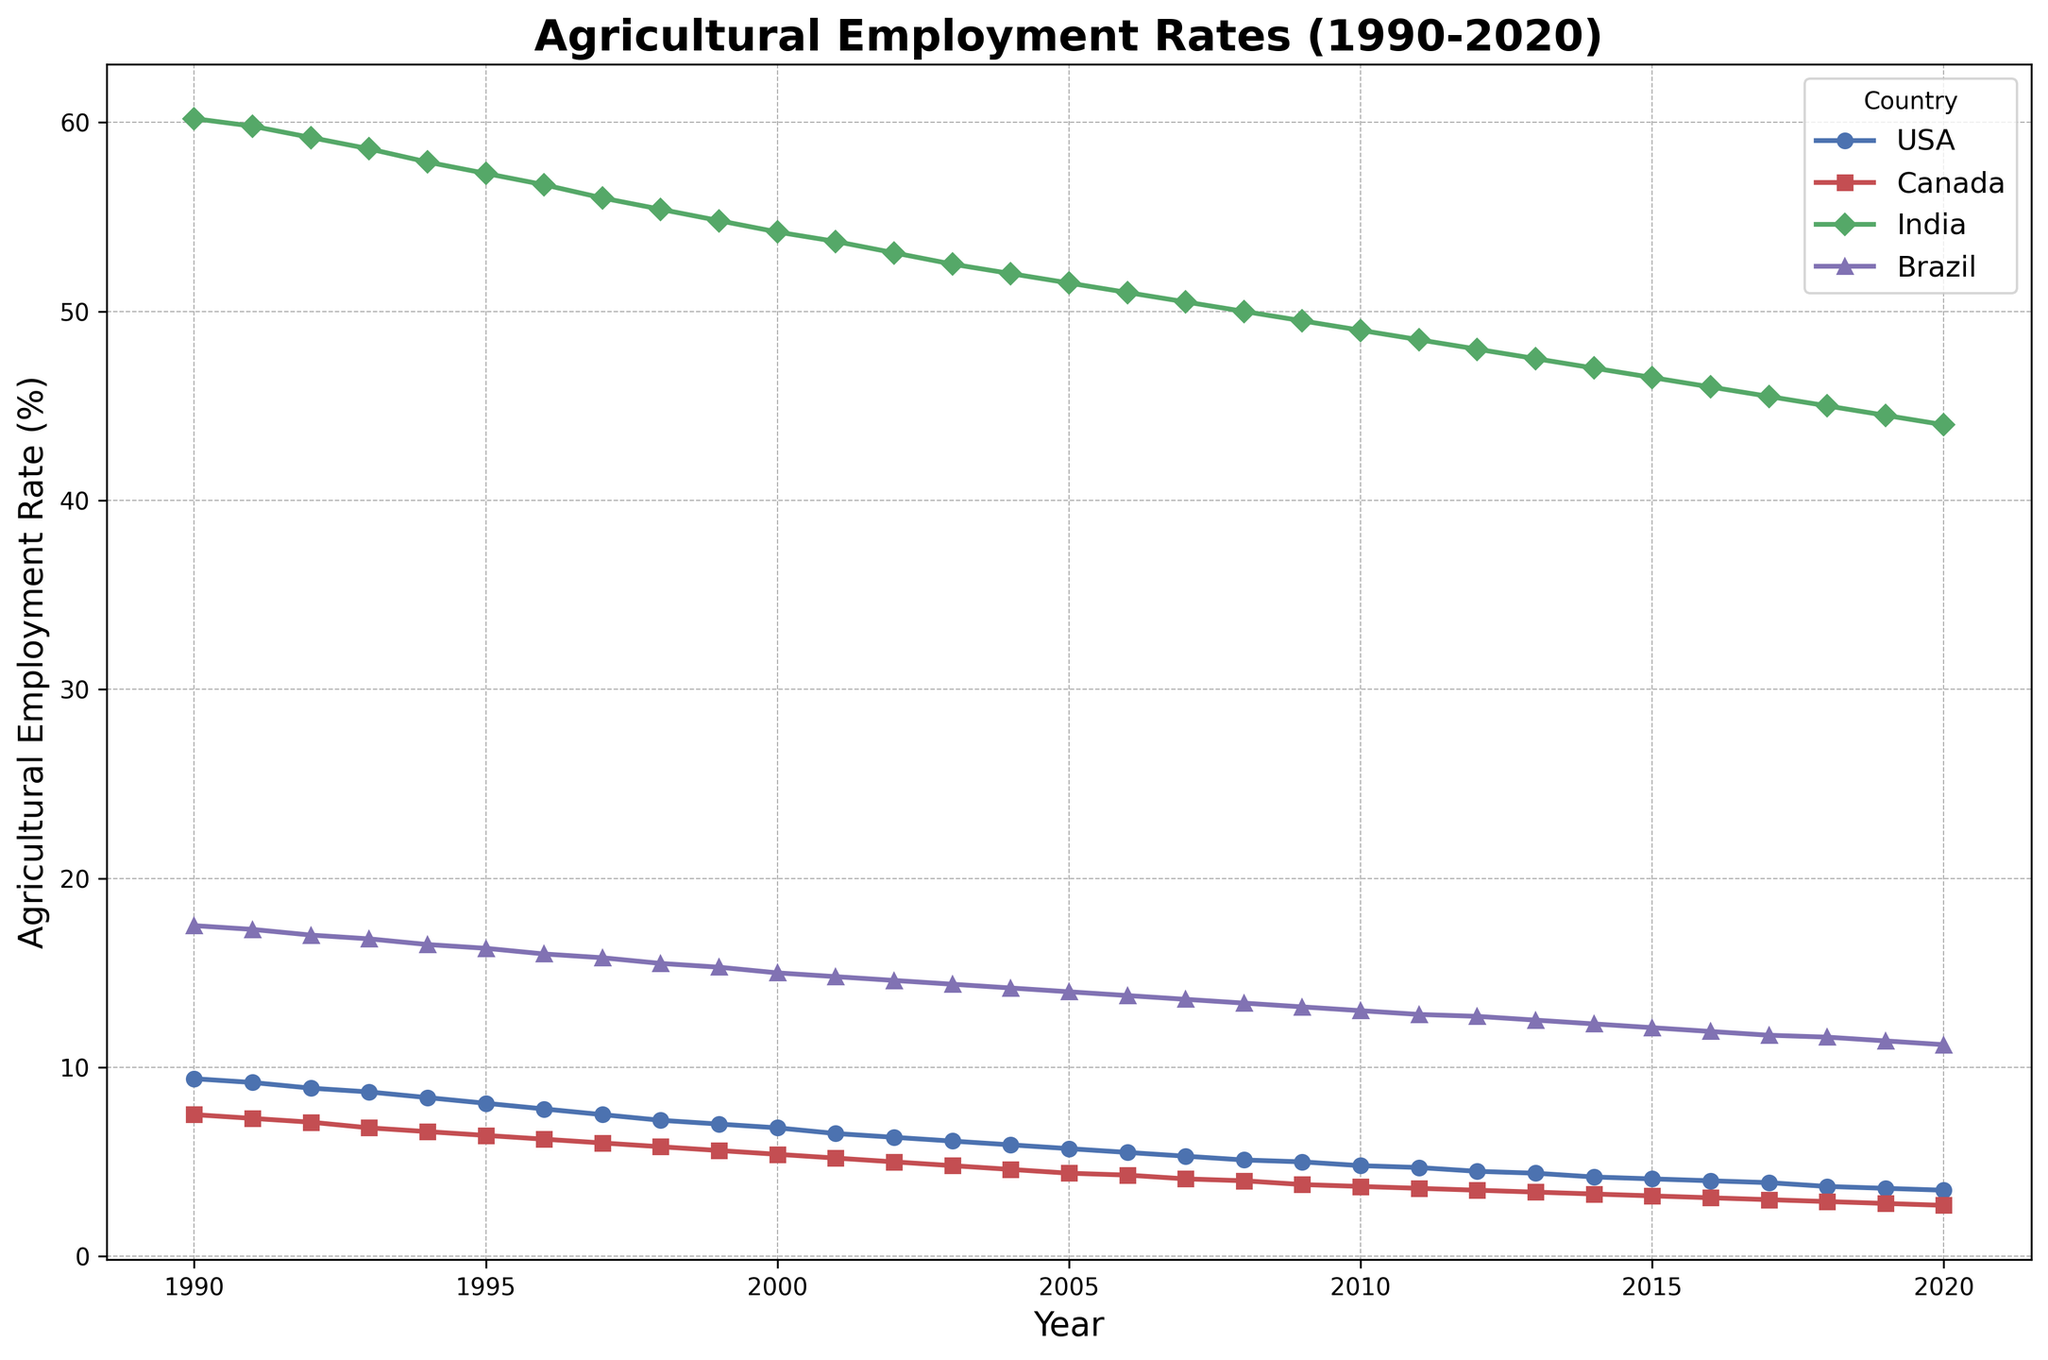What's the trend of agricultural employment rates in the USA over the past 30 years? The agricultural employment rate in the USA consistently decreased over the past 30 years, starting from 9.4% in 1990 and dropping to 3.5% in 2020.
Answer: Decreasing Which country had the highest agricultural employment rate in 1990? By examining the plot, India had the highest agricultural employment rate in 1990, significantly higher than the other countries, at 60.2%.
Answer: India By how much did the agricultural employment rate in Canada decrease from 1990 to 2020? The agricultural employment rate in Canada decreased from 7.5% in 1990 to 2.7% in 2020. The difference is 7.5% - 2.7% = 4.8%.
Answer: 4.8% Which country had the smallest decline in agricultural employment rate over the past 30 years? India had the smallest decline, decreasing from 60.2% in 1990 to 44.0% in 2020, a decline of 16.2%. Other countries had larger declines.
Answer: India In which year did Brazil's agricultural employment rate drop below 15%? The plot shows that Brazil's agricultural employment rate dropped below 15% in the year 1999.
Answer: 1999 What is the average agricultural employment rate in the USA during the 1990s? The average rate can be calculated by summing the values from 1990 to 1999 and then dividing by 10. (9.4 + 9.2 + 8.9 + 8.7 + 8.4 + 8.1 + 7.8 + 7.5 + 7.2 + 7.0) / 10 = 8.22%.
Answer: 8.22% How does the trend of agricultural employment rates in India compare to that in Brazil? Both India and Brazil show a declining trend in agricultural employment rates over the 30-year period. However, India's rates are much higher, starting around 60% and ending around 44%, while Brazil's rates start at 17.5% and end at 11.2%.
Answer: Both decreasing, India higher Between 2008 and 2018, which country had the most consistent (least variable) decline in agricultural employment rate? By visually inspecting the slopes of the line graphs between 2008 and 2018, Canada's decline appears most consistent.
Answer: Canada In which year did Canada's agricultural employment rate become less than 5%? The plot shows that Canada's agricultural employment rate became less than 5% in the year 2002.
Answer: 2002 What is the overall percentage decrease in agricultural employment rates in Brazil from 1990 to 2020? The percentage decrease can be calculated as (17.5% - 11.2%) / 17.5% * 100% = 36%.
Answer: 36% 